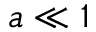Convert formula to latex. <formula><loc_0><loc_0><loc_500><loc_500>a \ll 1</formula> 